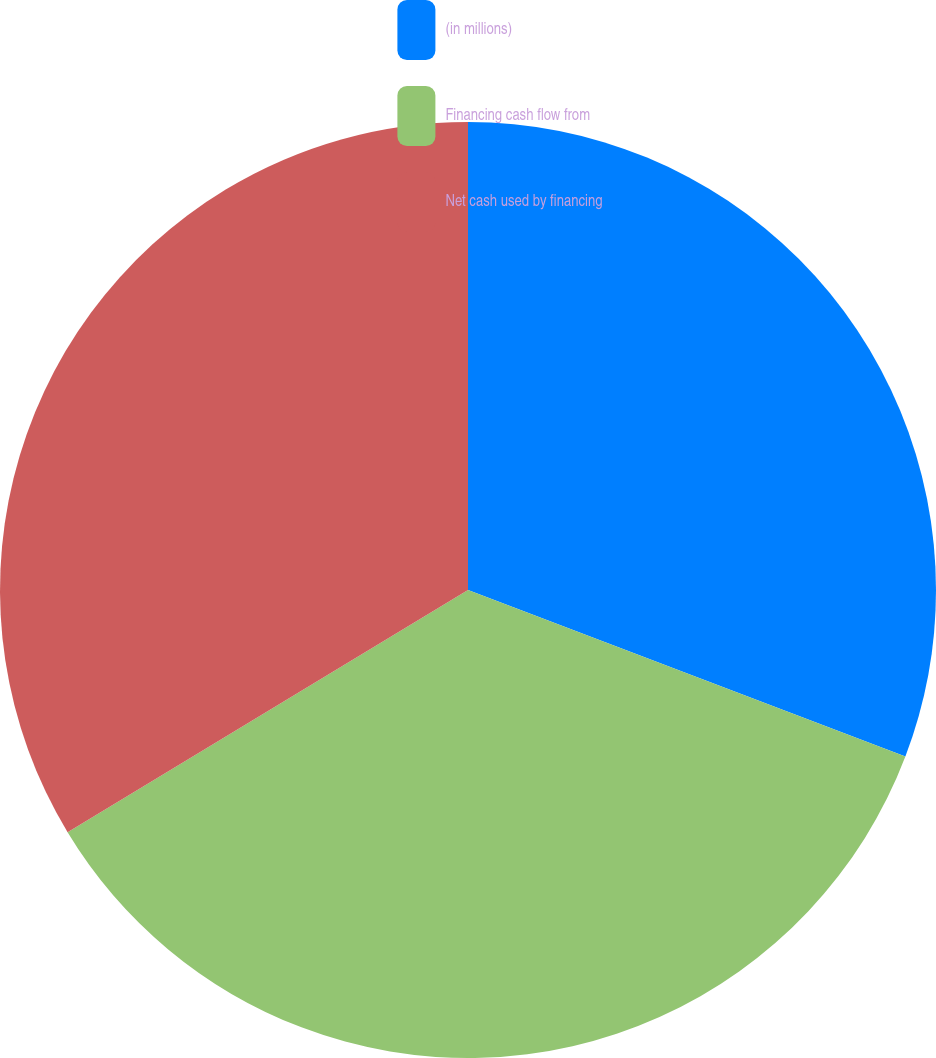Convert chart. <chart><loc_0><loc_0><loc_500><loc_500><pie_chart><fcel>(in millions)<fcel>Financing cash flow from<fcel>Net cash used by financing<nl><fcel>30.79%<fcel>35.55%<fcel>33.66%<nl></chart> 